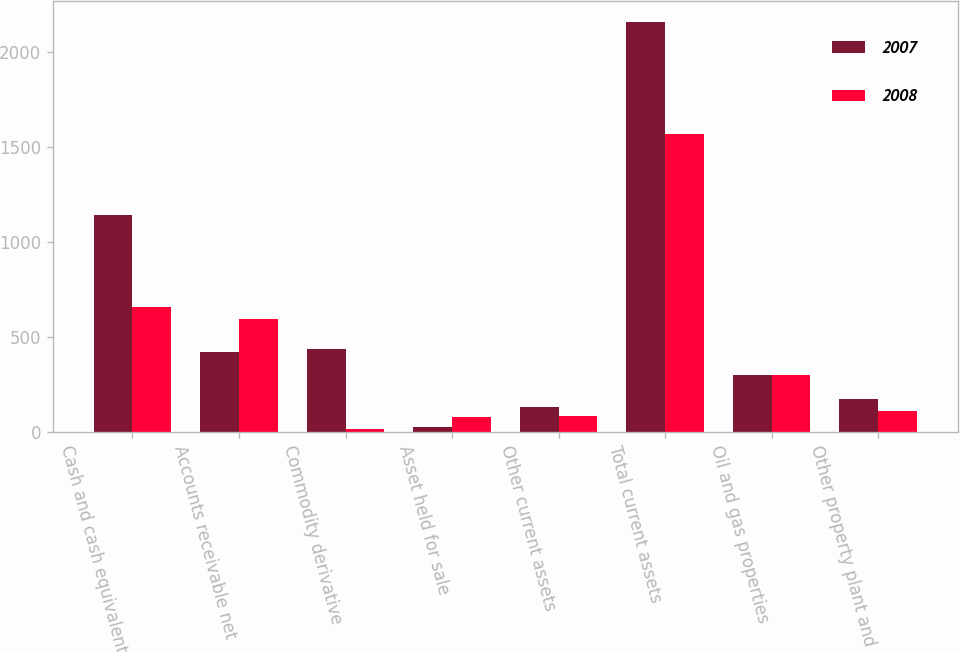Convert chart. <chart><loc_0><loc_0><loc_500><loc_500><stacked_bar_chart><ecel><fcel>Cash and cash equivalents<fcel>Accounts receivable net<fcel>Commodity derivative<fcel>Asset held for sale<fcel>Other current assets<fcel>Total current assets<fcel>Oil and gas properties<fcel>Other property plant and<nl><fcel>2007<fcel>1140<fcel>423<fcel>437<fcel>26<fcel>132<fcel>2158<fcel>299<fcel>175<nl><fcel>2008<fcel>660<fcel>594<fcel>15<fcel>82<fcel>87<fcel>1569<fcel>299<fcel>112<nl></chart> 